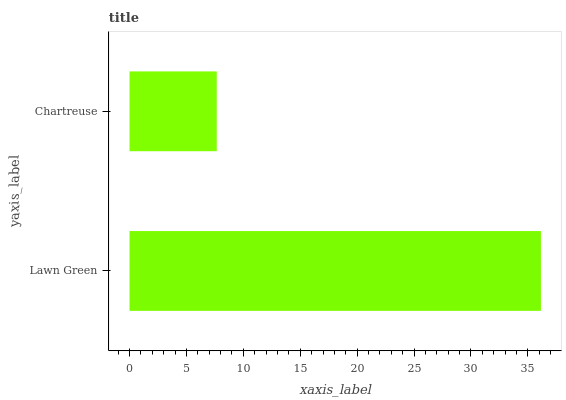Is Chartreuse the minimum?
Answer yes or no. Yes. Is Lawn Green the maximum?
Answer yes or no. Yes. Is Chartreuse the maximum?
Answer yes or no. No. Is Lawn Green greater than Chartreuse?
Answer yes or no. Yes. Is Chartreuse less than Lawn Green?
Answer yes or no. Yes. Is Chartreuse greater than Lawn Green?
Answer yes or no. No. Is Lawn Green less than Chartreuse?
Answer yes or no. No. Is Lawn Green the high median?
Answer yes or no. Yes. Is Chartreuse the low median?
Answer yes or no. Yes. Is Chartreuse the high median?
Answer yes or no. No. Is Lawn Green the low median?
Answer yes or no. No. 